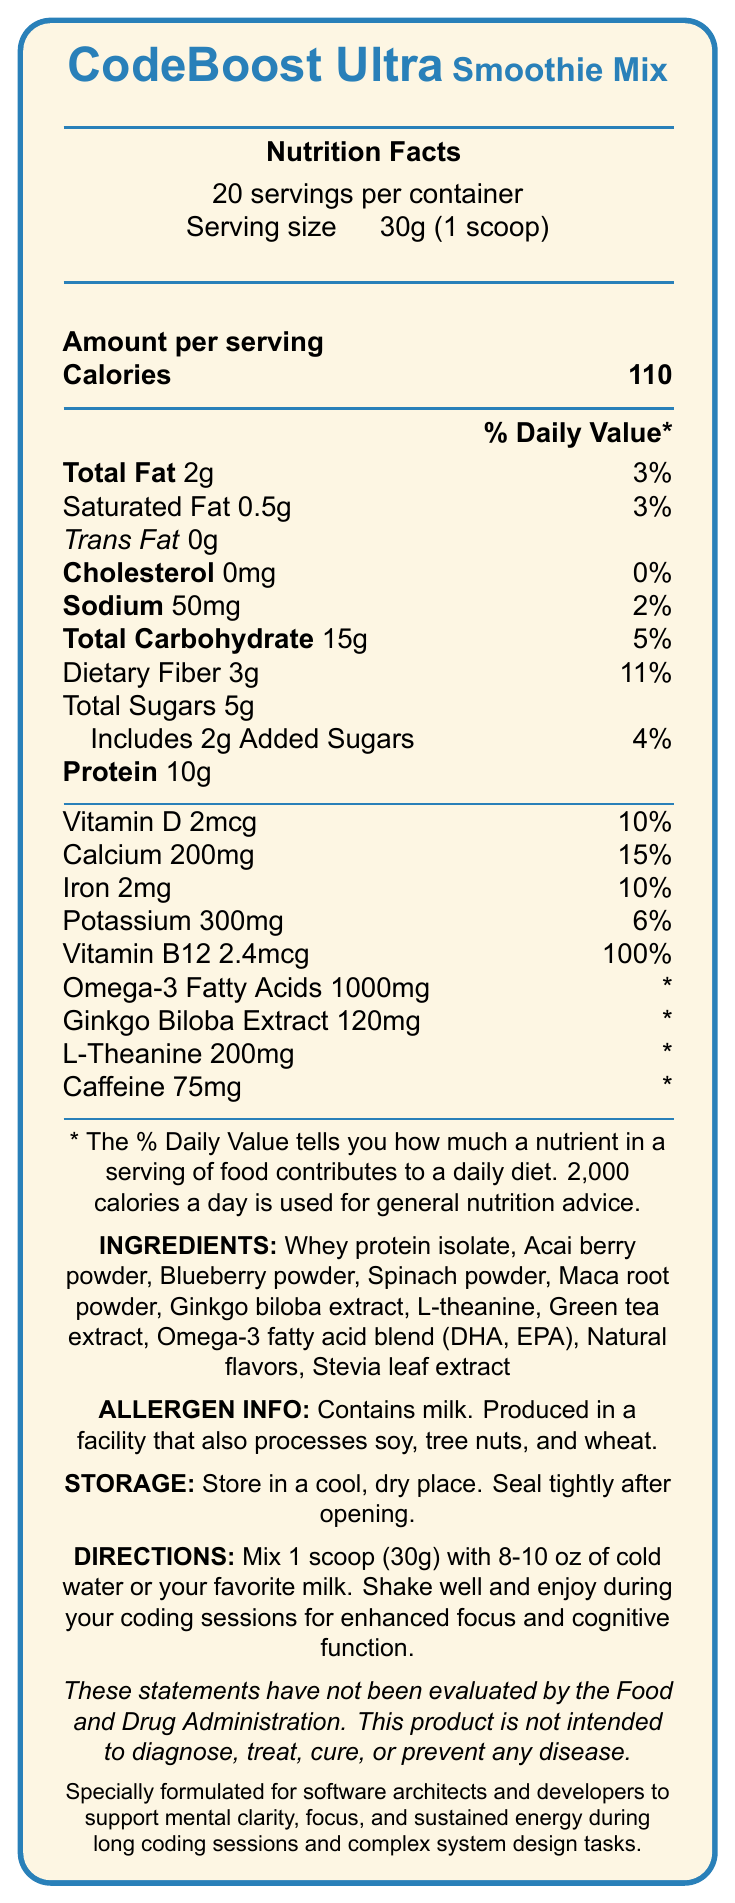What is the serving size of CodeBoost Ultra Smoothie Mix? The serving size is provided at the beginning of the nutrition facts section.
Answer: 30g (1 scoop) How many calories are there per serving? The calories per serving are listed in the "Amount per serving" section under "Calories."
Answer: 110 How much protein is in one serving? The amount of protein per serving is listed under the "Total Carbohydrate and Protein" section.
Answer: 10g What is the daily value percentage of dietary fiber in one serving? The daily value percentage for dietary fiber is listed next to its amount in the document.
Answer: 11% What is the amount of Vitamin B12 in one serving? The Vitamin B12 amount is listed under vitamins and minerals.
Answer: 2.4mcg Which of the following ingredients is not listed in CodeBoost Ultra Smoothie Mix? A. Whey protein isolate B. Spinach powder C. Soy protein D. Stevia leaf extract The ingredient list does not include soy protein.
Answer: C How many servings are in one container of CodeBoost Ultra Smoothie Mix? A. 15 B. 20 C. 25 D. 30 The document states that there are 20 servings per container.
Answer: B Does CodeBoost Ultra Smoothie Mix contain any added sugars? The document mentions that the product includes 2g of added sugars.
Answer: Yes How should the CodeBoost Ultra Smoothie Mix be stored? The storage instructions specify to store in a cool, dry place and to seal tightly after opening.
Answer: In a cool, dry place, sealed tightly after opening Is this product intended to diagnose, treat, cure, or prevent any disease? The disclaimer explicitly states that the product is not intended to diagnose, treat, cure, or prevent any disease and reminds that the presented statements have not been evaluated by the FDA.
Answer: No Does the smoothie mix contain any allergens? The product contains milk and is produced in a facility that processes soy, tree nuts, and wheat.
Answer: Yes Summarize the main idea of the document. The document focuses on the nutritional content, benefits, ingredients, and usage guidelines for a smoothie mix designed to enhance cognitive function for software professionals.
Answer: CodeBoost Ultra Smoothie Mix is a brain-boosting smoothie mix formulated to help software architects and developers maintain mental clarity, focus, and sustained energy during long coding sessions. It provides detailed nutritional information, ingredients, allergen info, storage and usage instructions, and a disclaimer about its intended use. What is the recommended fluid volume to mix with one serving of CodeBoost Ultra Smoothie Mix? The directions specify to mix one scoop with 8-10 oz of cold water or your favorite milk.
Answer: 8-10 oz of cold water or milk What’s the amount of caffeine in each serving? The amount of caffeine per serving is listed in the document under the additional nutrients section.
Answer: 75mg Can the exact benefit of Ginkgo Biloba Extract be determined from the document? The document lists Ginkgo Biloba Extract as an ingredient but does not specify the exact benefit or how it enhances cognitive function.
Answer: No 